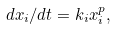<formula> <loc_0><loc_0><loc_500><loc_500>d x _ { i } / d t = k _ { i } x _ { i } ^ { p } ,</formula> 